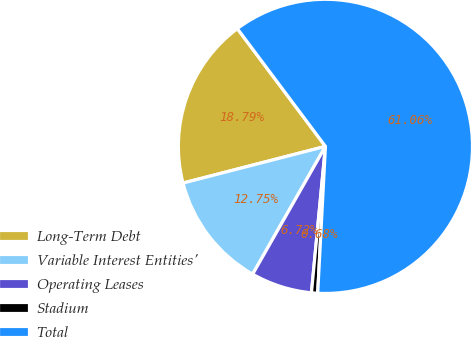Convert chart to OTSL. <chart><loc_0><loc_0><loc_500><loc_500><pie_chart><fcel>Long-Term Debt<fcel>Variable Interest Entities'<fcel>Operating Leases<fcel>Stadium<fcel>Total<nl><fcel>18.79%<fcel>12.75%<fcel>6.72%<fcel>0.68%<fcel>61.06%<nl></chart> 